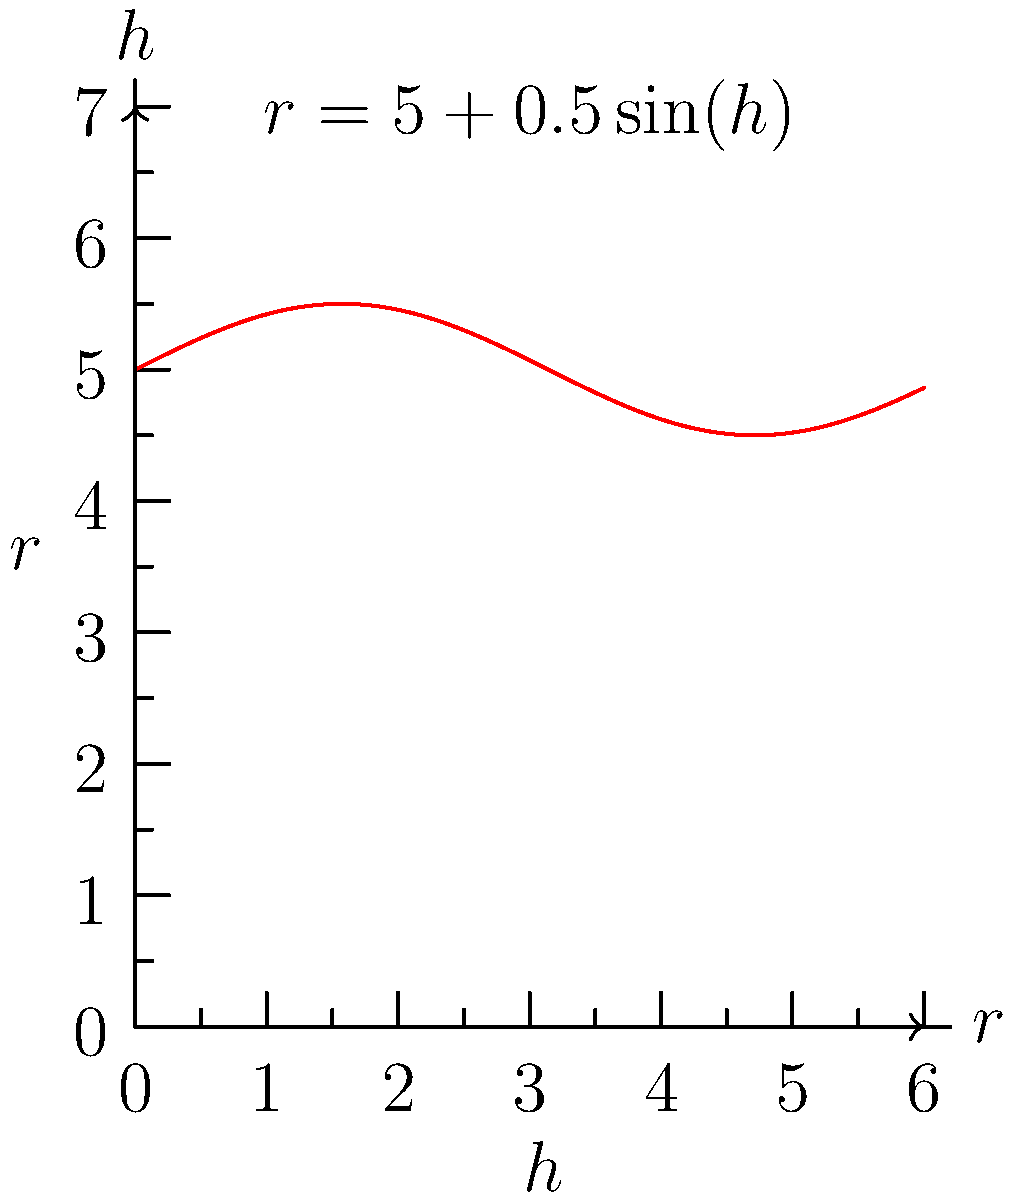An ice core sample from Antarctica is modeled as a cylinder with a varying radius. The radius $r$ (in cm) of the cylinder at height $h$ (in cm) is given by the function $r(h) = 5 + 0.5\sin(h)$, where $0 \leq h \leq 6$. Calculate the volume of the ice core sample. To find the volume of the ice core sample, we need to use the formula for the volume of a solid with known cross-sectional area:

$$V = \int_a^b A(h) \, dh$$

where $A(h)$ is the area of the cross-section at height $h$.

Step 1: Determine the cross-sectional area function.
The cross-section of the cylinder is a circle, so the area is $A(h) = \pi r(h)^2$.
$$A(h) = \pi (5 + 0.5\sin(h))^2$$

Step 2: Set up the integral for the volume.
$$V = \int_0^6 \pi (5 + 0.5\sin(h))^2 \, dh$$

Step 3: Expand the integrand.
$$V = \pi \int_0^6 (25 + 5\sin(h) + 0.25\sin^2(h)) \, dh$$

Step 4: Integrate each term.
$$V = \pi \left[25h - 5\cos(h) + \frac{1}{8}(2h - \sin(2h))\right]_0^6$$

Step 5: Evaluate the integral at the limits.
$$V = \pi \left[(150 - 5\cos(6) + \frac{3}{2} - \frac{1}{8}\sin(12)) - (0 - 5 + 0)\right]$$

Step 6: Simplify and calculate the final result.
$$V \approx 471.24 \text{ cm}^3$$
Answer: 471.24 cm³ 